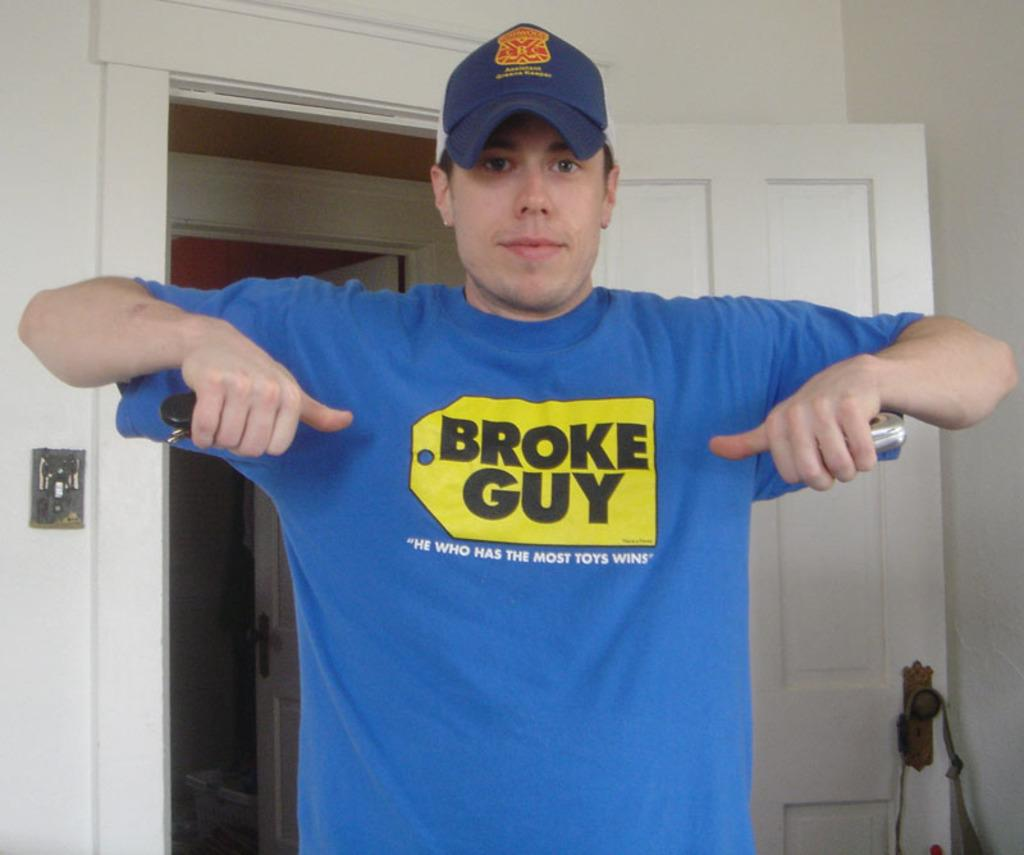Provide a one-sentence caption for the provided image. A man wearing a blue shirt that says Broke Guy in a Best Buy logo. 